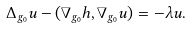Convert formula to latex. <formula><loc_0><loc_0><loc_500><loc_500>\Delta _ { g _ { 0 } } u - ( \nabla _ { g _ { 0 } } h , \nabla _ { g _ { 0 } } u ) = - \lambda u .</formula> 